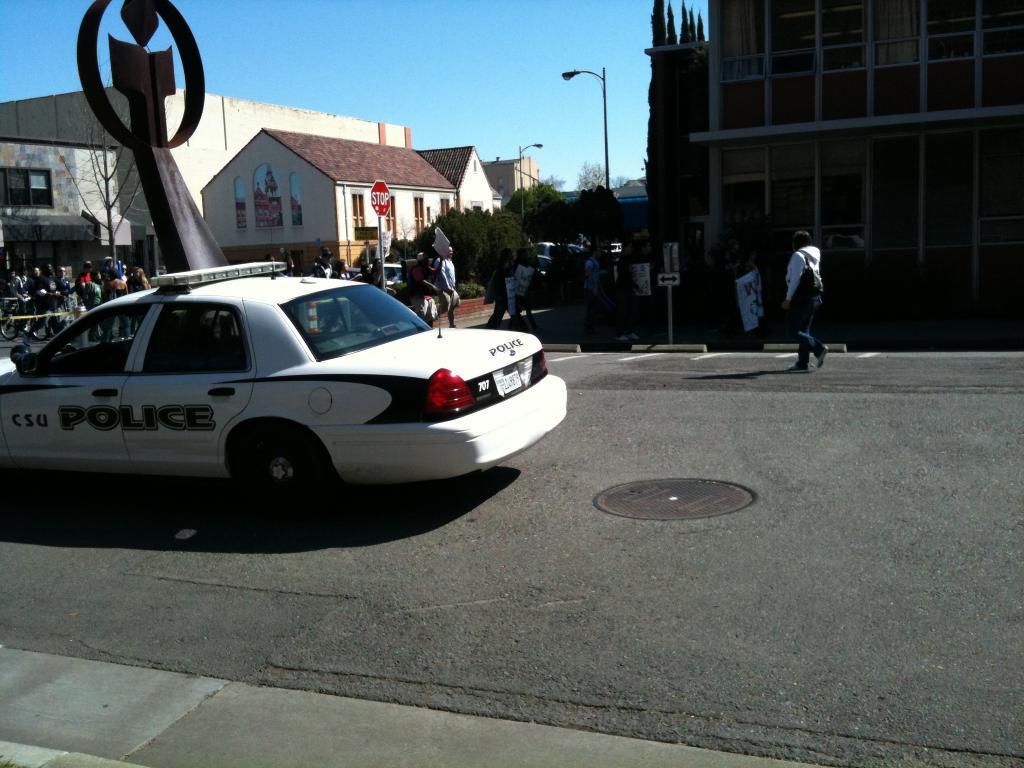Please provide a concise description of this image. In this image there are buildings and trees, in front of the building there few people walking on the road and there is a moving vehicle. At the center of the road there is a metal structure. In the background there is a sky. 